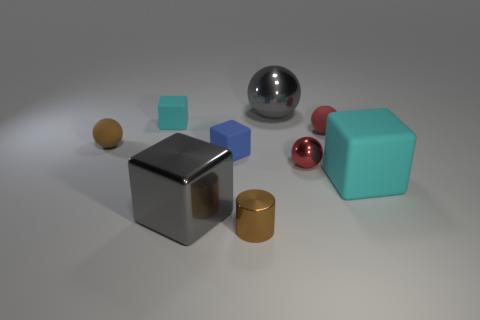Are there more blue cubes than tiny red cubes? Upon closer inspection, it appears that the number of blue cubes is indeed greater than the number of tiny red cubes in the image. 